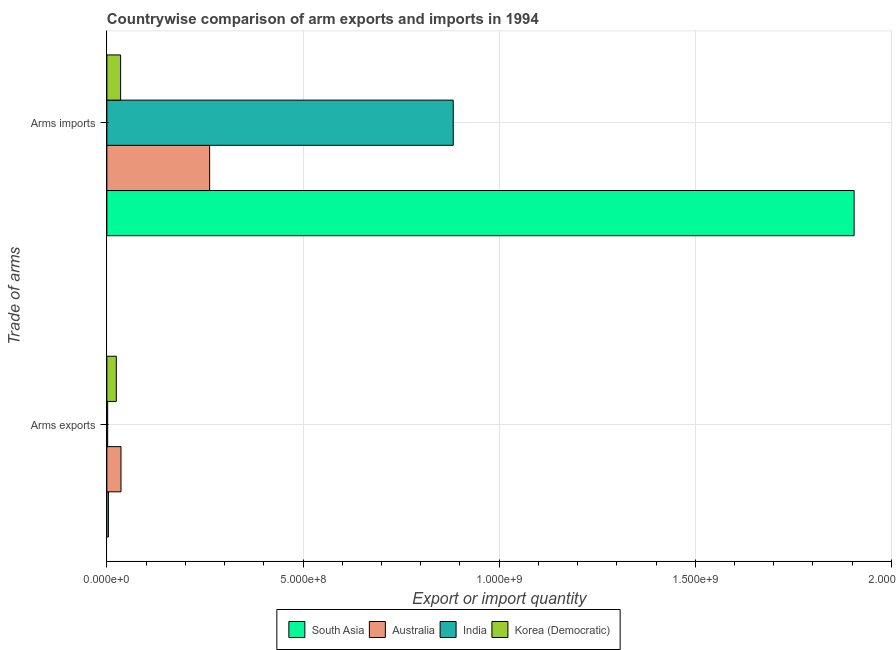How many groups of bars are there?
Provide a succinct answer. 2. Are the number of bars per tick equal to the number of legend labels?
Your response must be concise. Yes. Are the number of bars on each tick of the Y-axis equal?
Offer a very short reply. Yes. How many bars are there on the 2nd tick from the top?
Make the answer very short. 4. What is the label of the 1st group of bars from the top?
Offer a terse response. Arms imports. What is the arms exports in South Asia?
Ensure brevity in your answer.  4.00e+06. Across all countries, what is the maximum arms imports?
Your answer should be very brief. 1.90e+09. Across all countries, what is the minimum arms exports?
Ensure brevity in your answer.  2.00e+06. In which country was the arms imports maximum?
Give a very brief answer. South Asia. What is the total arms imports in the graph?
Ensure brevity in your answer.  3.08e+09. What is the difference between the arms imports in Australia and that in India?
Offer a very short reply. -6.21e+08. What is the difference between the arms imports in South Asia and the arms exports in Korea (Democratic)?
Your answer should be very brief. 1.88e+09. What is the average arms imports per country?
Offer a very short reply. 7.71e+08. What is the difference between the arms exports and arms imports in Australia?
Make the answer very short. -2.26e+08. What is the ratio of the arms exports in South Asia to that in Australia?
Your answer should be compact. 0.11. Is the arms imports in South Asia less than that in India?
Offer a terse response. No. In how many countries, is the arms exports greater than the average arms exports taken over all countries?
Give a very brief answer. 2. How many bars are there?
Make the answer very short. 8. Are all the bars in the graph horizontal?
Offer a very short reply. Yes. Are the values on the major ticks of X-axis written in scientific E-notation?
Provide a succinct answer. Yes. Does the graph contain any zero values?
Keep it short and to the point. No. Where does the legend appear in the graph?
Offer a very short reply. Bottom center. How are the legend labels stacked?
Keep it short and to the point. Horizontal. What is the title of the graph?
Make the answer very short. Countrywise comparison of arm exports and imports in 1994. Does "OECD members" appear as one of the legend labels in the graph?
Provide a short and direct response. No. What is the label or title of the X-axis?
Provide a short and direct response. Export or import quantity. What is the label or title of the Y-axis?
Offer a terse response. Trade of arms. What is the Export or import quantity in South Asia in Arms exports?
Offer a very short reply. 4.00e+06. What is the Export or import quantity of Australia in Arms exports?
Provide a succinct answer. 3.60e+07. What is the Export or import quantity of India in Arms exports?
Your answer should be compact. 2.00e+06. What is the Export or import quantity of Korea (Democratic) in Arms exports?
Offer a terse response. 2.40e+07. What is the Export or import quantity of South Asia in Arms imports?
Offer a terse response. 1.90e+09. What is the Export or import quantity of Australia in Arms imports?
Offer a terse response. 2.62e+08. What is the Export or import quantity in India in Arms imports?
Offer a very short reply. 8.83e+08. What is the Export or import quantity in Korea (Democratic) in Arms imports?
Give a very brief answer. 3.50e+07. Across all Trade of arms, what is the maximum Export or import quantity in South Asia?
Ensure brevity in your answer.  1.90e+09. Across all Trade of arms, what is the maximum Export or import quantity in Australia?
Offer a very short reply. 2.62e+08. Across all Trade of arms, what is the maximum Export or import quantity of India?
Offer a terse response. 8.83e+08. Across all Trade of arms, what is the maximum Export or import quantity in Korea (Democratic)?
Provide a succinct answer. 3.50e+07. Across all Trade of arms, what is the minimum Export or import quantity in South Asia?
Your answer should be compact. 4.00e+06. Across all Trade of arms, what is the minimum Export or import quantity of Australia?
Your response must be concise. 3.60e+07. Across all Trade of arms, what is the minimum Export or import quantity of India?
Make the answer very short. 2.00e+06. Across all Trade of arms, what is the minimum Export or import quantity of Korea (Democratic)?
Your answer should be compact. 2.40e+07. What is the total Export or import quantity of South Asia in the graph?
Give a very brief answer. 1.91e+09. What is the total Export or import quantity of Australia in the graph?
Provide a short and direct response. 2.98e+08. What is the total Export or import quantity in India in the graph?
Give a very brief answer. 8.85e+08. What is the total Export or import quantity in Korea (Democratic) in the graph?
Offer a terse response. 5.90e+07. What is the difference between the Export or import quantity in South Asia in Arms exports and that in Arms imports?
Provide a succinct answer. -1.90e+09. What is the difference between the Export or import quantity in Australia in Arms exports and that in Arms imports?
Provide a short and direct response. -2.26e+08. What is the difference between the Export or import quantity of India in Arms exports and that in Arms imports?
Your answer should be compact. -8.81e+08. What is the difference between the Export or import quantity in Korea (Democratic) in Arms exports and that in Arms imports?
Offer a very short reply. -1.10e+07. What is the difference between the Export or import quantity of South Asia in Arms exports and the Export or import quantity of Australia in Arms imports?
Ensure brevity in your answer.  -2.58e+08. What is the difference between the Export or import quantity of South Asia in Arms exports and the Export or import quantity of India in Arms imports?
Your answer should be compact. -8.79e+08. What is the difference between the Export or import quantity of South Asia in Arms exports and the Export or import quantity of Korea (Democratic) in Arms imports?
Provide a short and direct response. -3.10e+07. What is the difference between the Export or import quantity of Australia in Arms exports and the Export or import quantity of India in Arms imports?
Provide a short and direct response. -8.47e+08. What is the difference between the Export or import quantity of India in Arms exports and the Export or import quantity of Korea (Democratic) in Arms imports?
Give a very brief answer. -3.30e+07. What is the average Export or import quantity of South Asia per Trade of arms?
Offer a terse response. 9.54e+08. What is the average Export or import quantity of Australia per Trade of arms?
Your response must be concise. 1.49e+08. What is the average Export or import quantity of India per Trade of arms?
Keep it short and to the point. 4.42e+08. What is the average Export or import quantity of Korea (Democratic) per Trade of arms?
Offer a very short reply. 2.95e+07. What is the difference between the Export or import quantity of South Asia and Export or import quantity of Australia in Arms exports?
Your response must be concise. -3.20e+07. What is the difference between the Export or import quantity of South Asia and Export or import quantity of Korea (Democratic) in Arms exports?
Give a very brief answer. -2.00e+07. What is the difference between the Export or import quantity in Australia and Export or import quantity in India in Arms exports?
Your response must be concise. 3.40e+07. What is the difference between the Export or import quantity of India and Export or import quantity of Korea (Democratic) in Arms exports?
Offer a very short reply. -2.20e+07. What is the difference between the Export or import quantity in South Asia and Export or import quantity in Australia in Arms imports?
Your answer should be compact. 1.64e+09. What is the difference between the Export or import quantity in South Asia and Export or import quantity in India in Arms imports?
Your answer should be very brief. 1.02e+09. What is the difference between the Export or import quantity of South Asia and Export or import quantity of Korea (Democratic) in Arms imports?
Offer a terse response. 1.87e+09. What is the difference between the Export or import quantity of Australia and Export or import quantity of India in Arms imports?
Your answer should be compact. -6.21e+08. What is the difference between the Export or import quantity of Australia and Export or import quantity of Korea (Democratic) in Arms imports?
Your answer should be very brief. 2.27e+08. What is the difference between the Export or import quantity in India and Export or import quantity in Korea (Democratic) in Arms imports?
Your answer should be compact. 8.48e+08. What is the ratio of the Export or import quantity in South Asia in Arms exports to that in Arms imports?
Give a very brief answer. 0. What is the ratio of the Export or import quantity of Australia in Arms exports to that in Arms imports?
Your response must be concise. 0.14. What is the ratio of the Export or import quantity in India in Arms exports to that in Arms imports?
Offer a terse response. 0. What is the ratio of the Export or import quantity of Korea (Democratic) in Arms exports to that in Arms imports?
Your response must be concise. 0.69. What is the difference between the highest and the second highest Export or import quantity of South Asia?
Make the answer very short. 1.90e+09. What is the difference between the highest and the second highest Export or import quantity in Australia?
Offer a very short reply. 2.26e+08. What is the difference between the highest and the second highest Export or import quantity of India?
Give a very brief answer. 8.81e+08. What is the difference between the highest and the second highest Export or import quantity of Korea (Democratic)?
Offer a very short reply. 1.10e+07. What is the difference between the highest and the lowest Export or import quantity of South Asia?
Your answer should be very brief. 1.90e+09. What is the difference between the highest and the lowest Export or import quantity in Australia?
Make the answer very short. 2.26e+08. What is the difference between the highest and the lowest Export or import quantity of India?
Your answer should be compact. 8.81e+08. What is the difference between the highest and the lowest Export or import quantity of Korea (Democratic)?
Offer a terse response. 1.10e+07. 